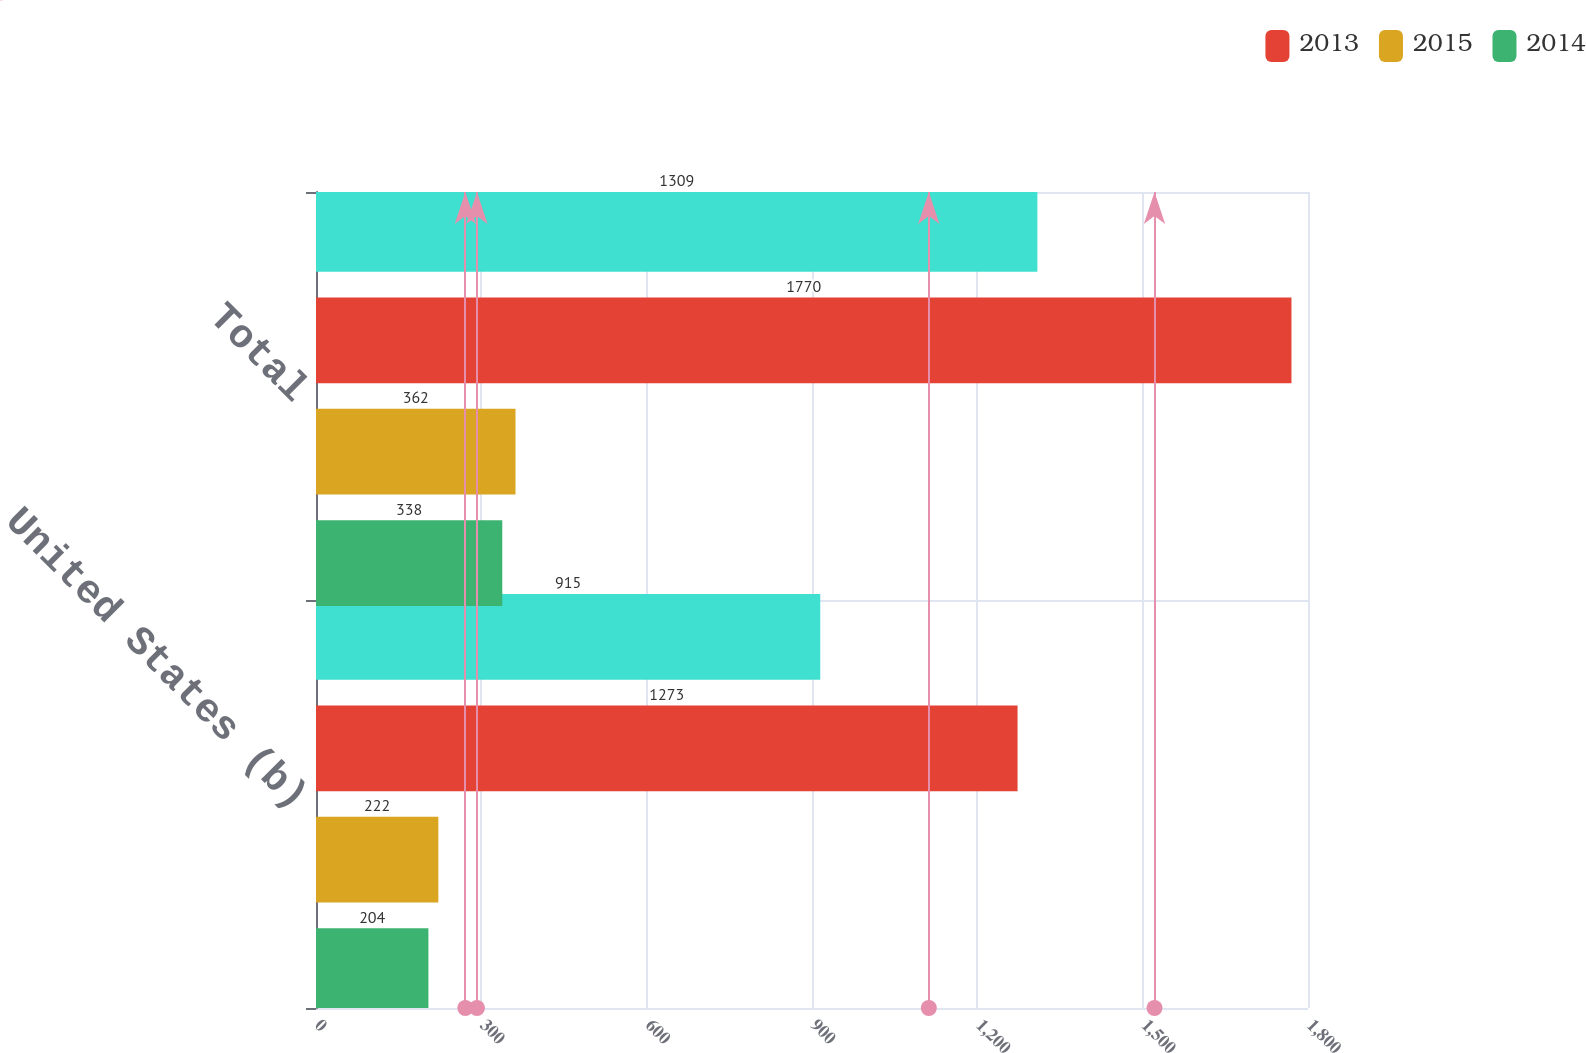Convert chart. <chart><loc_0><loc_0><loc_500><loc_500><stacked_bar_chart><ecel><fcel>United States (b)<fcel>Total<nl><fcel>nan<fcel>915<fcel>1309<nl><fcel>2013<fcel>1273<fcel>1770<nl><fcel>2015<fcel>222<fcel>362<nl><fcel>2014<fcel>204<fcel>338<nl></chart> 